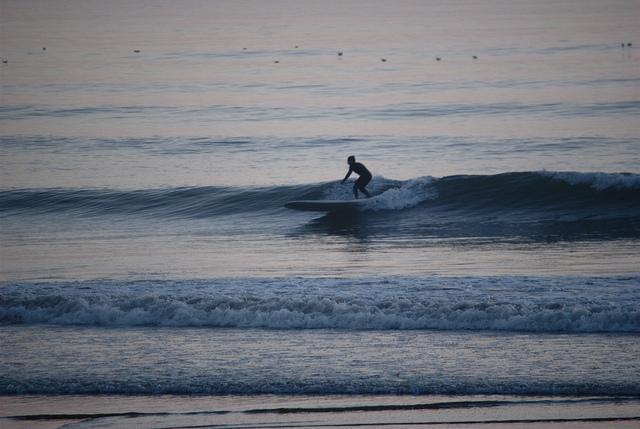How many elephants are in the left hand picture?
Give a very brief answer. 0. 